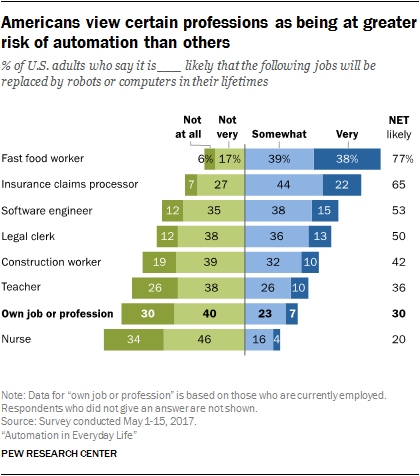Indicate a few pertinent items in this graphic. Fast food workers are at a high risk of automation, making them one of the professions most likely to be replaced by machines. The likely value of an individual's own job or profession is 0.3. 